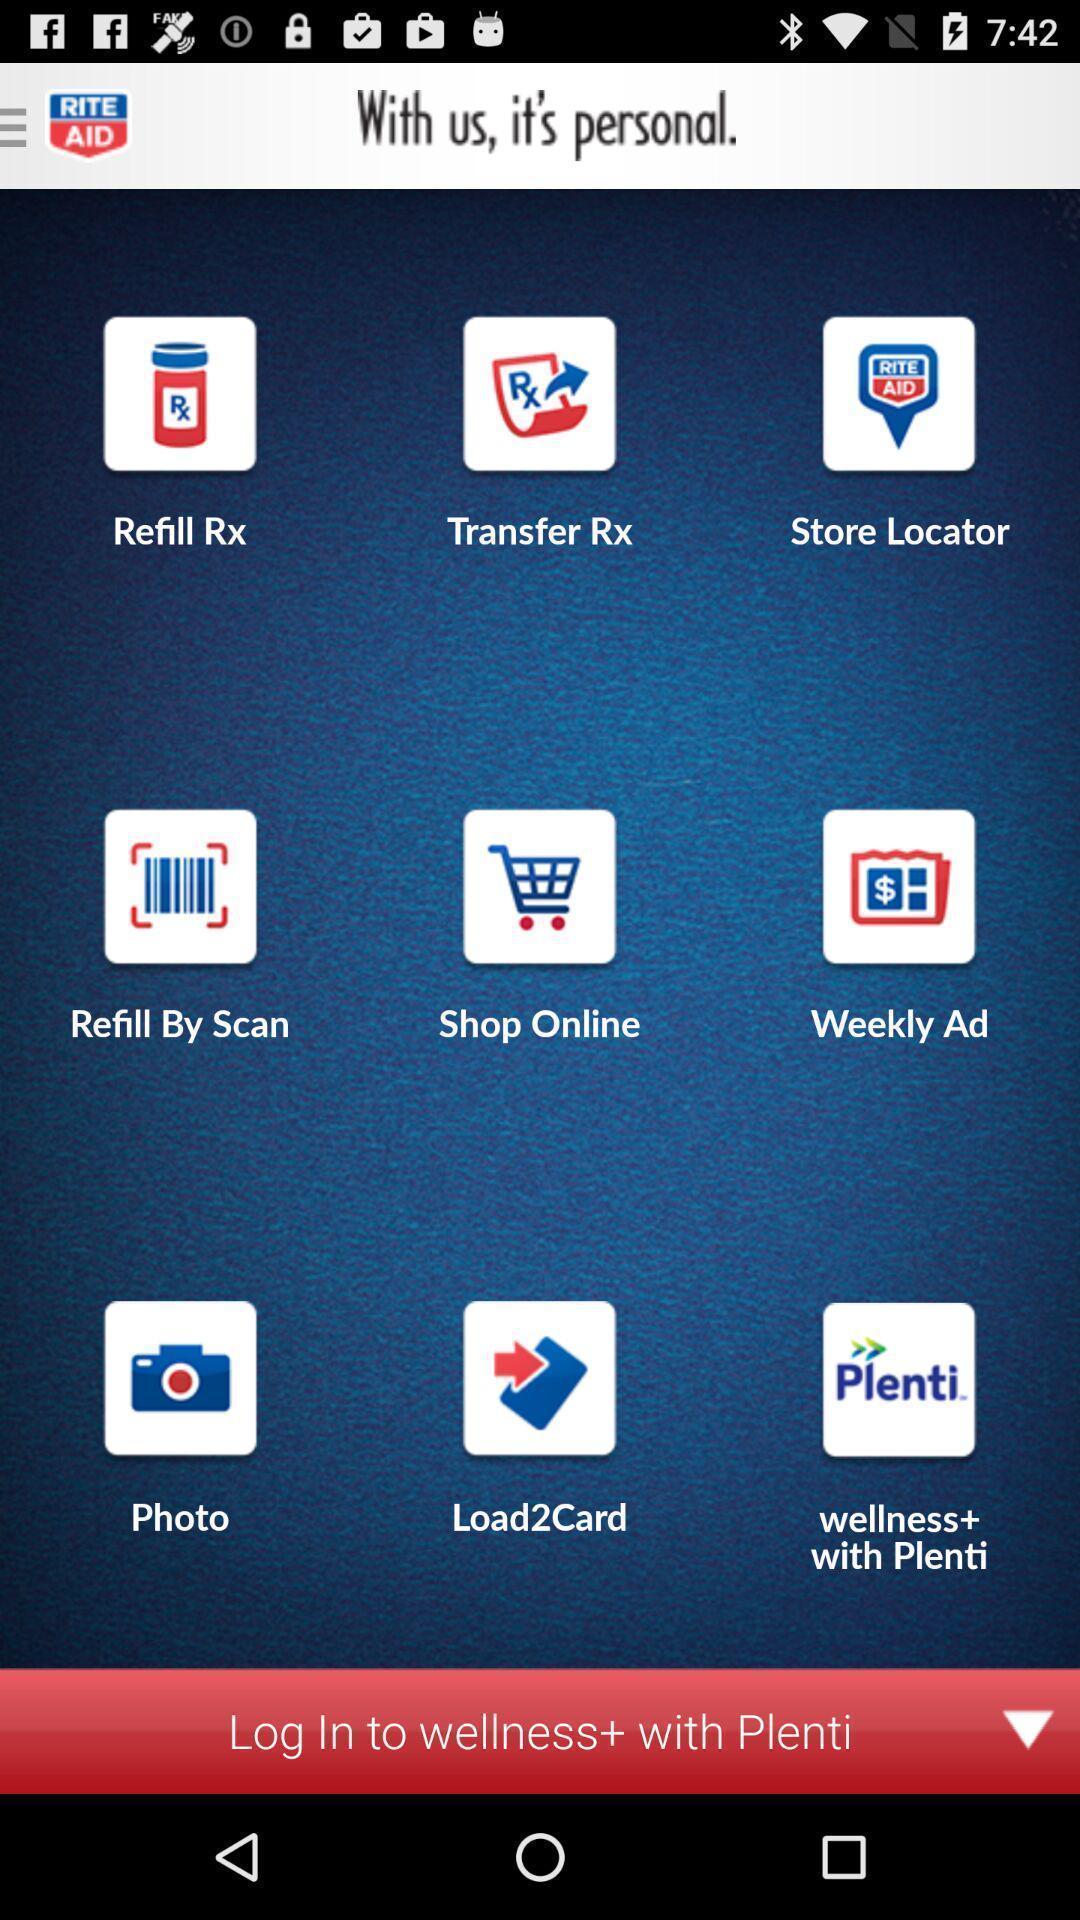Explain the elements present in this screenshot. Page showing multiple services and login option for an application. 